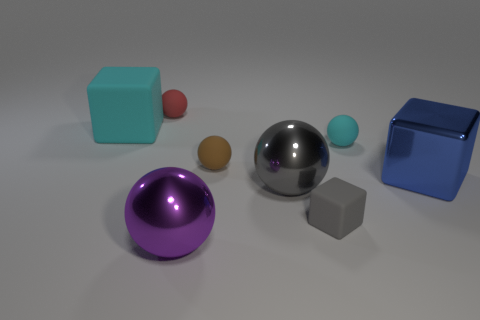Can you tell me what materials the objects in the image appear to be made of? The objects in the image seem to be made of various materials. The two cubes and the sphere in the center appear to have a metallic finish suggesting they might be made of metal. The smaller objects, such as the small sphere and the small cube, have a more matte finish, potentially indicating a plastic or rubber composition. Is there any pattern to how the objects are arranged? There's no immediately discernible pattern to the arrangement of the objects. They seem randomly placed, with varying distances between each other, and no clear order based on size, color, or material. 